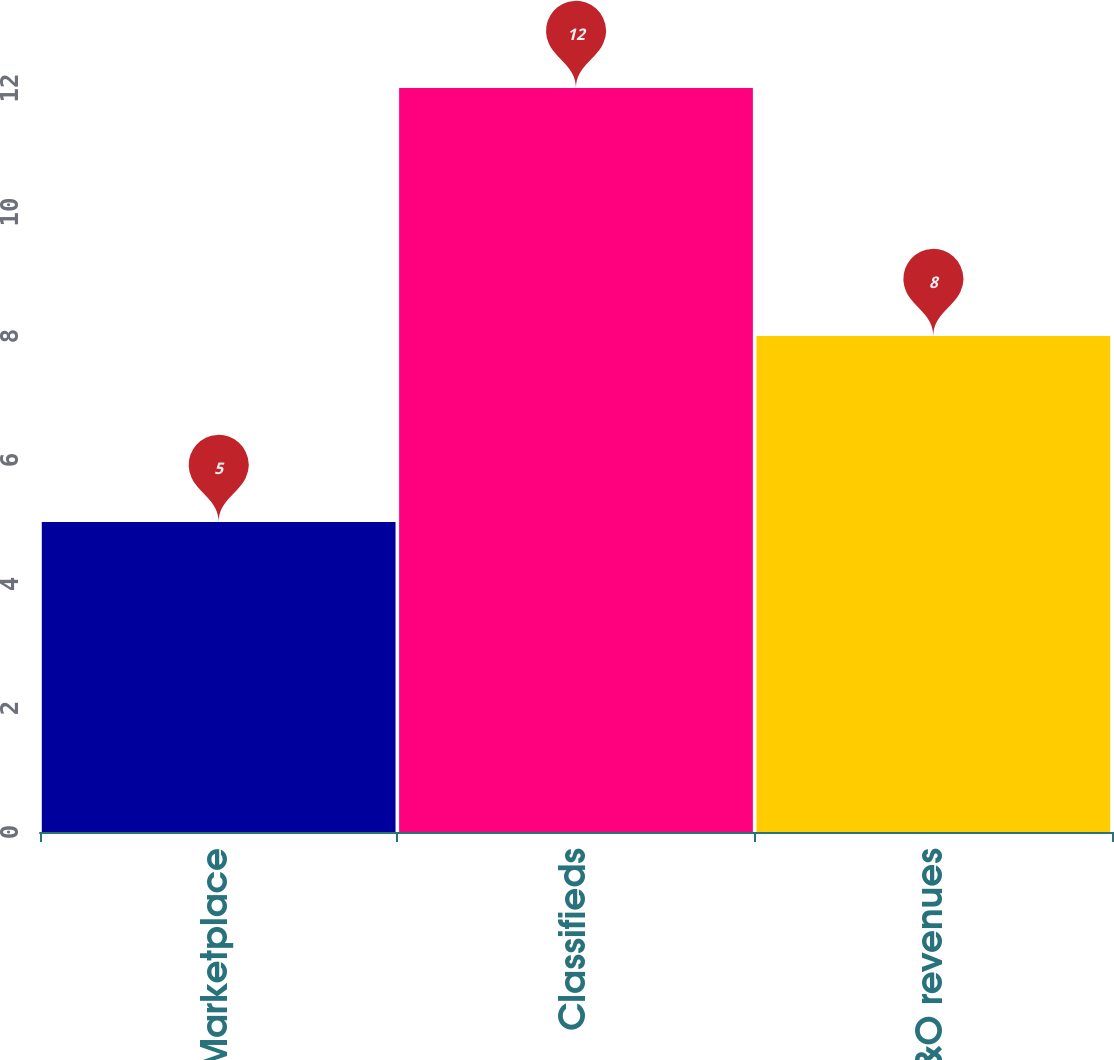Convert chart. <chart><loc_0><loc_0><loc_500><loc_500><bar_chart><fcel>Marketplace<fcel>Classifieds<fcel>Total MS&O revenues<nl><fcel>5<fcel>12<fcel>8<nl></chart> 